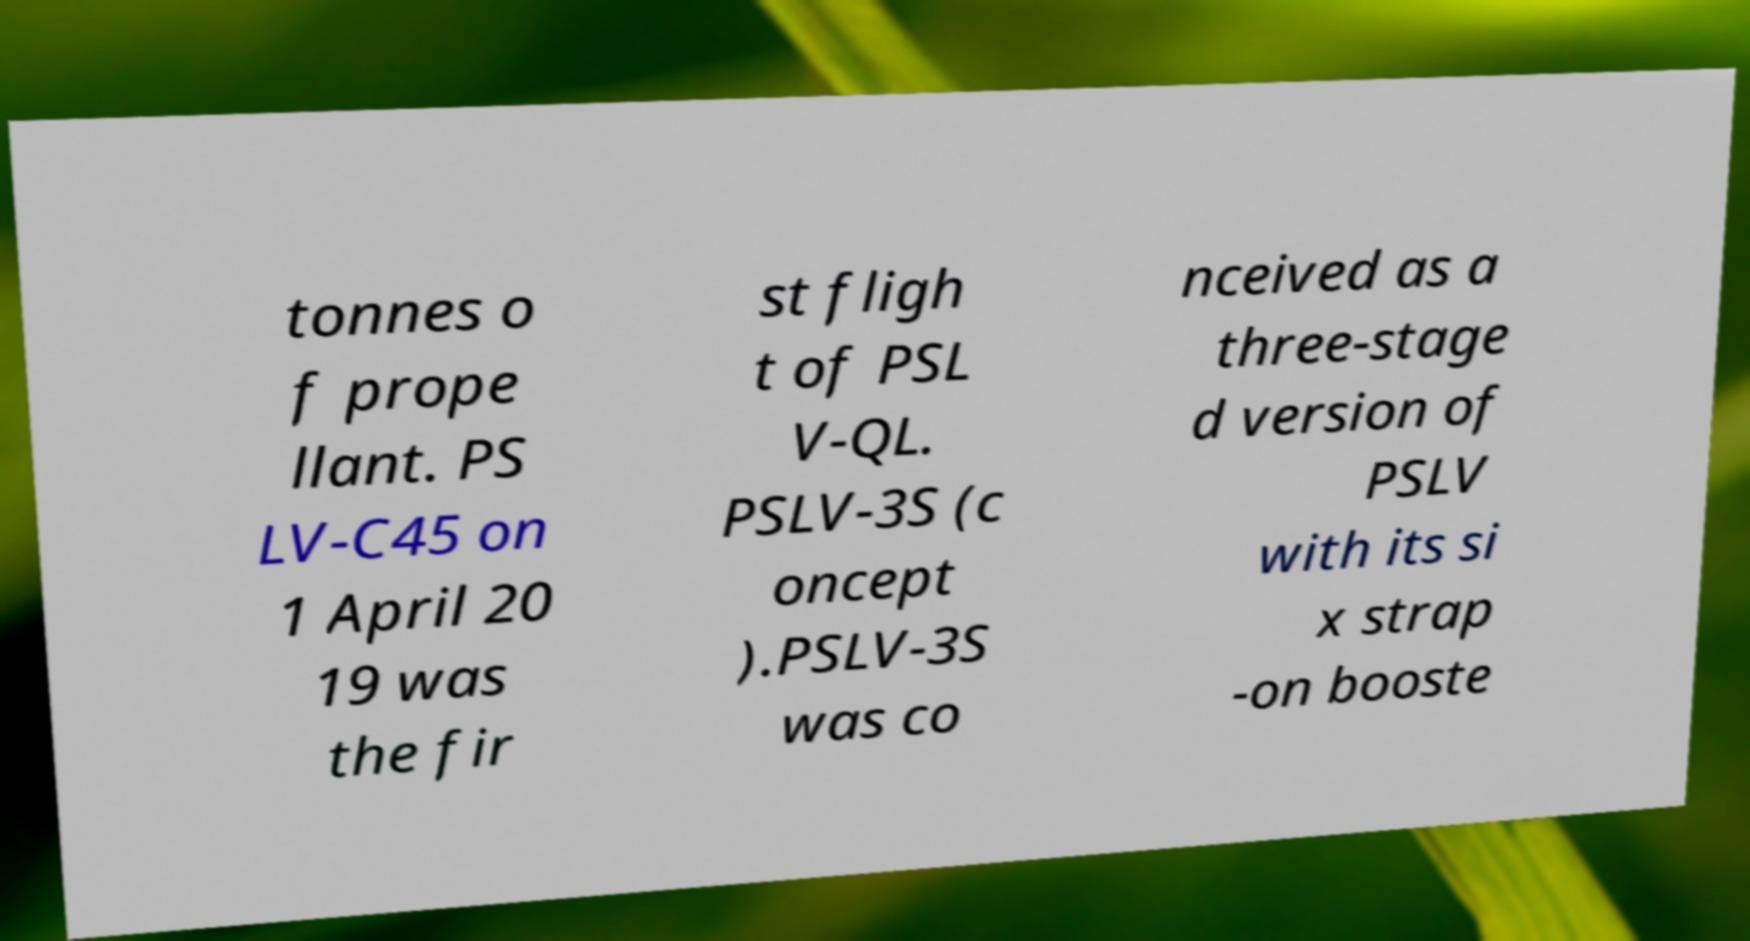Can you accurately transcribe the text from the provided image for me? tonnes o f prope llant. PS LV-C45 on 1 April 20 19 was the fir st fligh t of PSL V-QL. PSLV-3S (c oncept ).PSLV-3S was co nceived as a three-stage d version of PSLV with its si x strap -on booste 